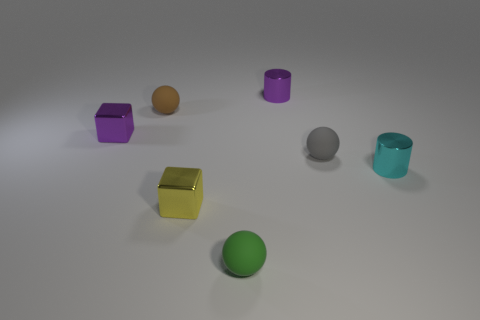Subtract all tiny brown balls. How many balls are left? 2 Subtract all cubes. How many objects are left? 5 Add 3 cubes. How many objects exist? 10 Subtract all gray spheres. How many spheres are left? 2 Subtract 1 cylinders. How many cylinders are left? 1 Add 6 small cyan shiny cylinders. How many small cyan shiny cylinders are left? 7 Add 5 big gray rubber cylinders. How many big gray rubber cylinders exist? 5 Subtract 0 green cylinders. How many objects are left? 7 Subtract all green cylinders. Subtract all green balls. How many cylinders are left? 2 Subtract all red cylinders. How many green balls are left? 1 